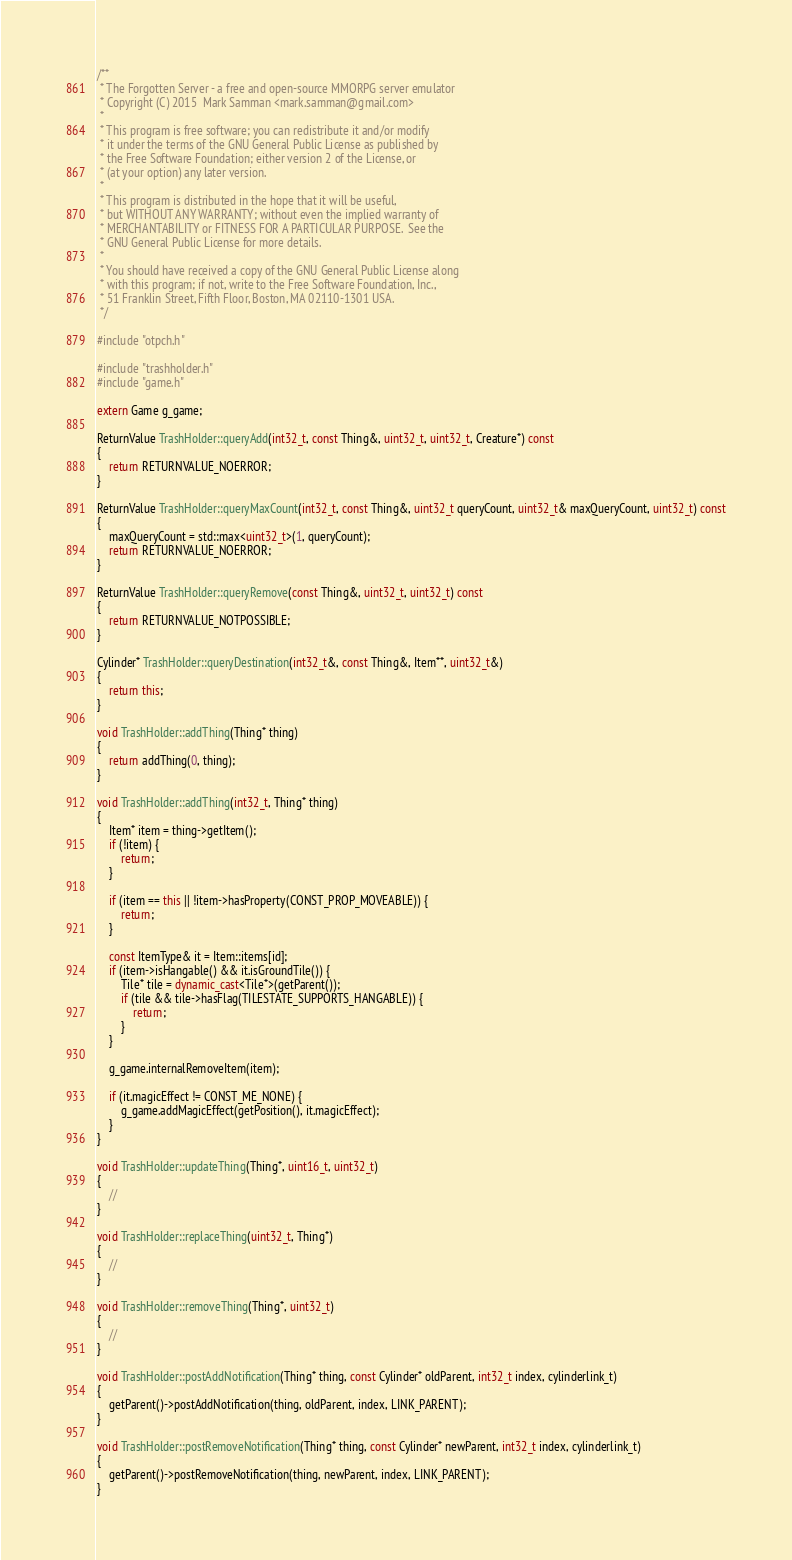<code> <loc_0><loc_0><loc_500><loc_500><_C++_>/**
 * The Forgotten Server - a free and open-source MMORPG server emulator
 * Copyright (C) 2015  Mark Samman <mark.samman@gmail.com>
 *
 * This program is free software; you can redistribute it and/or modify
 * it under the terms of the GNU General Public License as published by
 * the Free Software Foundation; either version 2 of the License, or
 * (at your option) any later version.
 *
 * This program is distributed in the hope that it will be useful,
 * but WITHOUT ANY WARRANTY; without even the implied warranty of
 * MERCHANTABILITY or FITNESS FOR A PARTICULAR PURPOSE.  See the
 * GNU General Public License for more details.
 *
 * You should have received a copy of the GNU General Public License along
 * with this program; if not, write to the Free Software Foundation, Inc.,
 * 51 Franklin Street, Fifth Floor, Boston, MA 02110-1301 USA.
 */

#include "otpch.h"

#include "trashholder.h"
#include "game.h"

extern Game g_game;

ReturnValue TrashHolder::queryAdd(int32_t, const Thing&, uint32_t, uint32_t, Creature*) const
{
	return RETURNVALUE_NOERROR;
}

ReturnValue TrashHolder::queryMaxCount(int32_t, const Thing&, uint32_t queryCount, uint32_t& maxQueryCount, uint32_t) const
{
	maxQueryCount = std::max<uint32_t>(1, queryCount);
	return RETURNVALUE_NOERROR;
}

ReturnValue TrashHolder::queryRemove(const Thing&, uint32_t, uint32_t) const
{
	return RETURNVALUE_NOTPOSSIBLE;
}

Cylinder* TrashHolder::queryDestination(int32_t&, const Thing&, Item**, uint32_t&)
{
	return this;
}

void TrashHolder::addThing(Thing* thing)
{
	return addThing(0, thing);
}

void TrashHolder::addThing(int32_t, Thing* thing)
{
	Item* item = thing->getItem();
	if (!item) {
		return;
	}

	if (item == this || !item->hasProperty(CONST_PROP_MOVEABLE)) {
		return;
	}

	const ItemType& it = Item::items[id];
	if (item->isHangable() && it.isGroundTile()) {
		Tile* tile = dynamic_cast<Tile*>(getParent());
		if (tile && tile->hasFlag(TILESTATE_SUPPORTS_HANGABLE)) {
			return;
		}
	}

	g_game.internalRemoveItem(item);

	if (it.magicEffect != CONST_ME_NONE) {
		g_game.addMagicEffect(getPosition(), it.magicEffect);
	}
}

void TrashHolder::updateThing(Thing*, uint16_t, uint32_t)
{
	//
}

void TrashHolder::replaceThing(uint32_t, Thing*)
{
	//
}

void TrashHolder::removeThing(Thing*, uint32_t)
{
	//
}

void TrashHolder::postAddNotification(Thing* thing, const Cylinder* oldParent, int32_t index, cylinderlink_t)
{
	getParent()->postAddNotification(thing, oldParent, index, LINK_PARENT);
}

void TrashHolder::postRemoveNotification(Thing* thing, const Cylinder* newParent, int32_t index, cylinderlink_t)
{
	getParent()->postRemoveNotification(thing, newParent, index, LINK_PARENT);
}
</code> 